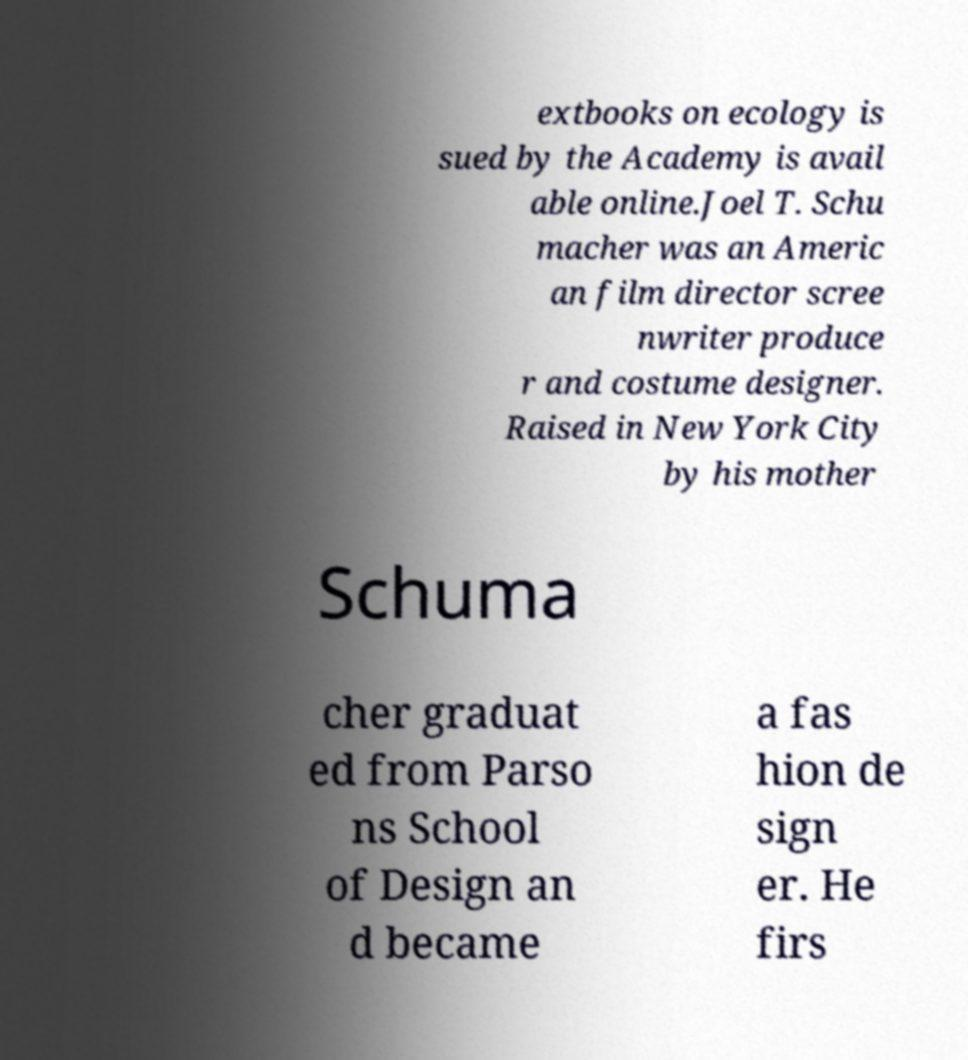I need the written content from this picture converted into text. Can you do that? extbooks on ecology is sued by the Academy is avail able online.Joel T. Schu macher was an Americ an film director scree nwriter produce r and costume designer. Raised in New York City by his mother Schuma cher graduat ed from Parso ns School of Design an d became a fas hion de sign er. He firs 